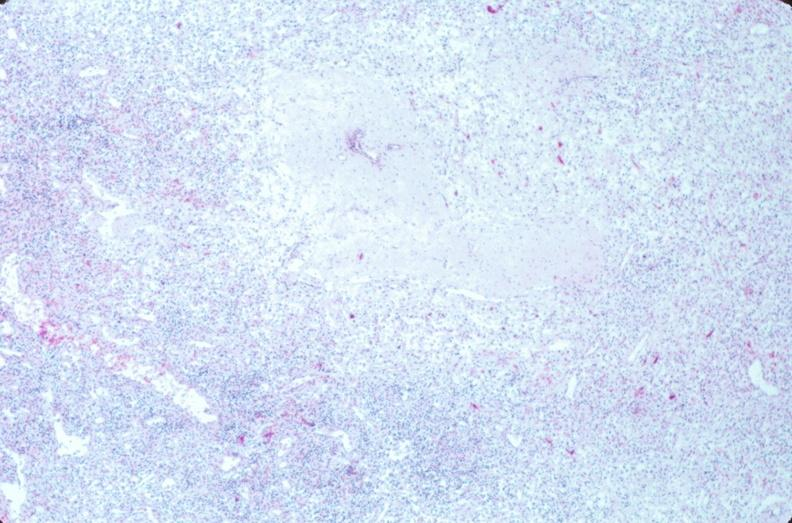does cryptosporidia show lymph nodes, nodular sclerosing hodgkins disease?
Answer the question using a single word or phrase. No 